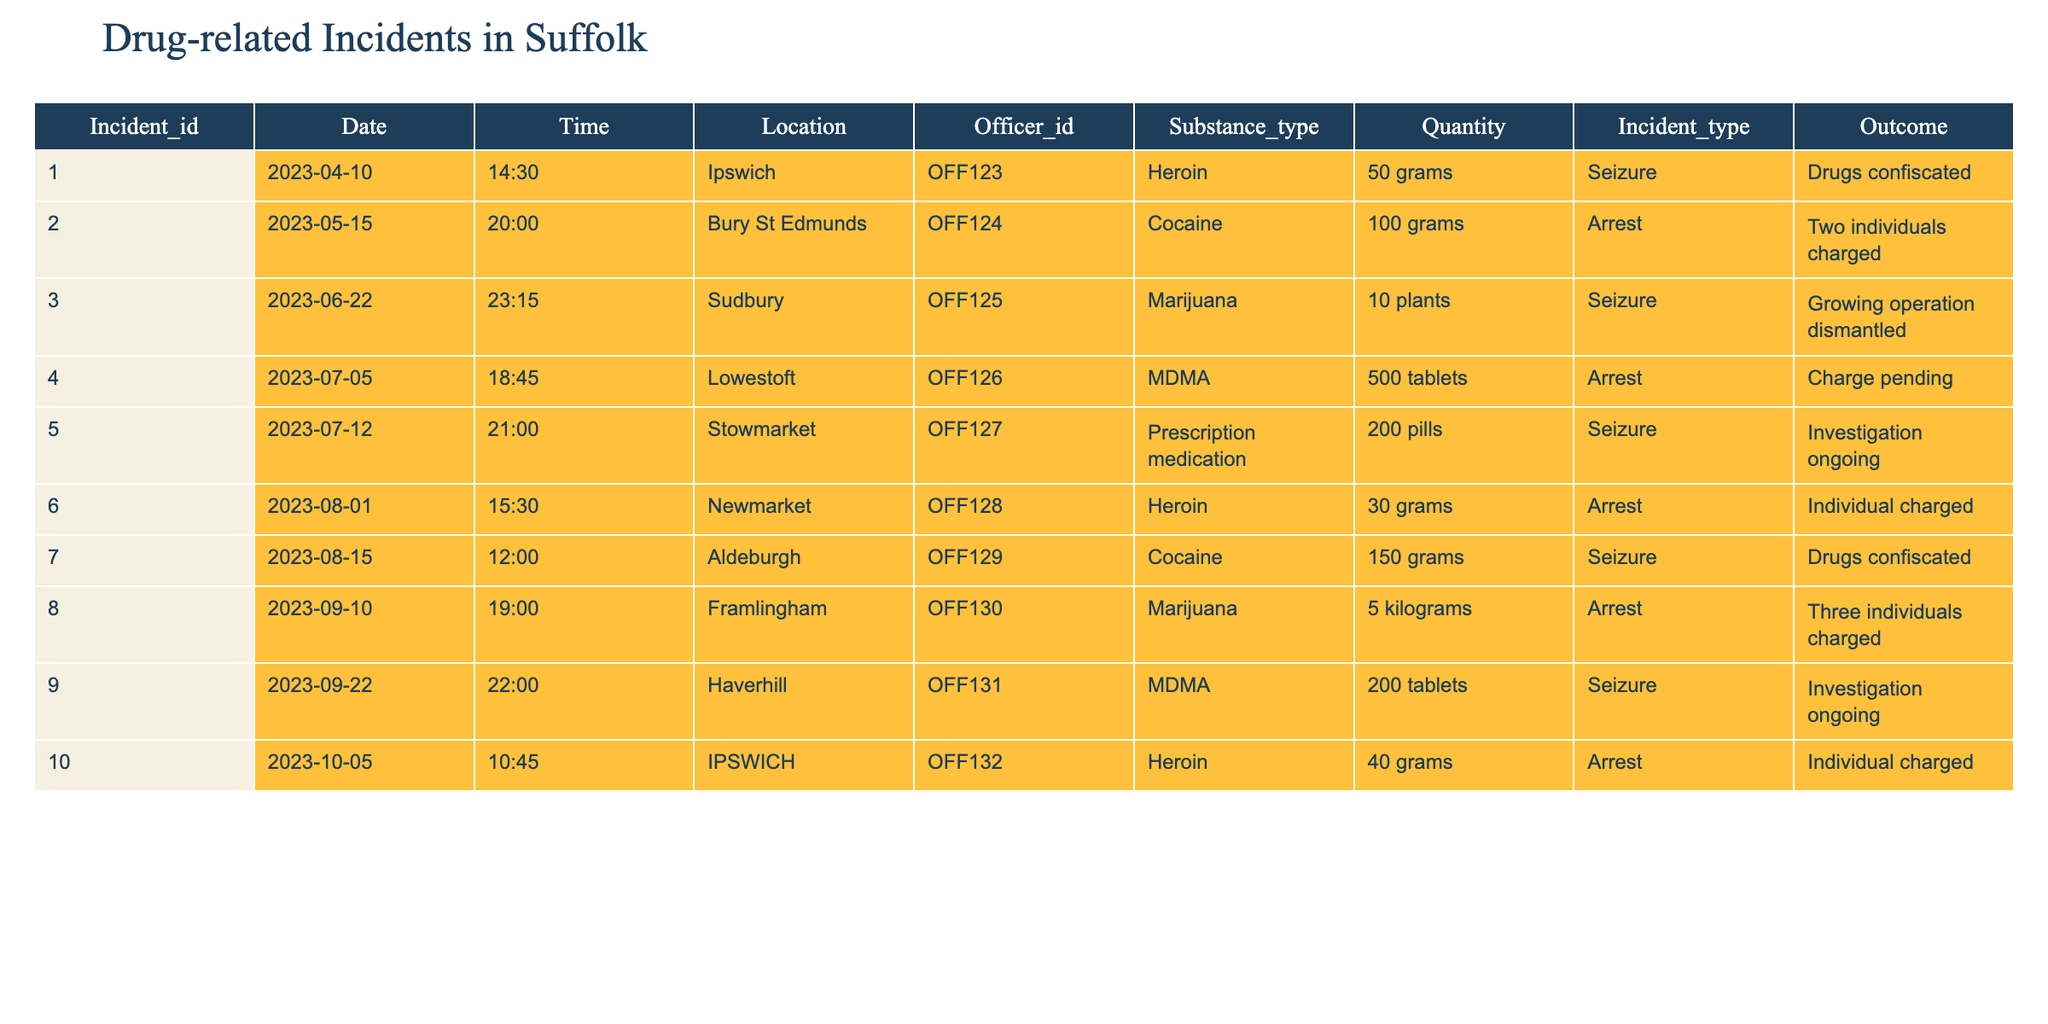What was the most common substance type reported in the incidents? By reviewing the "Substance_Type" column, we can see that "Heroin" appears three times, which is more than any other substance.
Answer: Heroin How many total arrests were made based on the incidents? Looking at the "Incident_Type" column, there are five incidents categorized as "Arrest."
Answer: 5 What is the total quantity of marijuana involved in the incidents? We identify two incidents with marijuana, one involving 10 plants and another involving 5 kilograms. Since 1 kilogram equals 1000 grams, we convert 5 kilograms to grams which is 5000 grams. Adding them gives us a total of 10 + 5000 = 5010 grams of marijuana.
Answer: 5010 grams Did any incidents involve prescription medication? Reviewing the "Substance_Type," there is one incident listed as "Prescription medication," confirming that it did occur.
Answer: Yes Which location had the highest quantity of cocaine reported? In the table, the incident at Bury St Edmunds reported 100 grams and the Aldeburgh incident reported 150 grams. The largest amount of cocaine is from Aldeburgh, with 150 grams.
Answer: Aldeburgh How many incidents had an outcome of "Investigation ongoing"? There are two entries in the "Outcome" column that indicate "Investigation ongoing," corresponding to the incidents involving prescription medication and MDMA.
Answer: 2 What substance type had the highest total quantity reported in the seizures? We sum the quantities from "Seizures" for each substance type. For heroin, there are 50 grams + 30 grams = 80 grams; for cocaine, there are 150 grams; for marijuana (5 kilograms converted to grams is 5000 grams); for MDMA, 200 tablets (assumed to be one unit here); and for prescription medication, it’s 200 pills. The highest is marijuana at 5000 grams.
Answer: Marijuana Based on the table, were there more incidents related to seizures or arrests? Counting the "Incident_Type," we see there are five entries under "Seizure" and five under "Arrest," indicating they are equal.
Answer: Equal Which officer had the most incidents reported? We analyze the "Officer_ID" and see that each officer has one or two incidents, with the highest at OFF129 and OFF130 (both one incident each), so no officer had more than one.
Answer: None (equal distribution) Calculate the average quantity of drugs per incident in grams across all incidents reported. Summing up all quantities in grams (50 + 100 + 10 + 500 + 200 + 30 + 150 + 5000 + 200 + 40 = 5530 grams) and divide by the number of incidents (10), the average is 5530/10 = 553 grams per incident.
Answer: 553 grams 